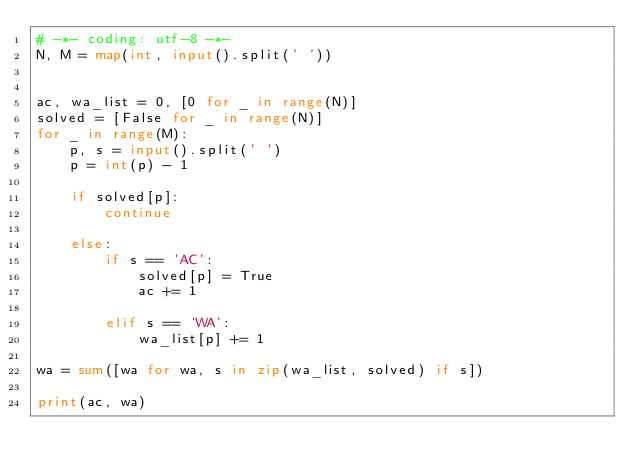<code> <loc_0><loc_0><loc_500><loc_500><_Python_># -*- coding: utf-8 -*-
N, M = map(int, input().split(' '))


ac, wa_list = 0, [0 for _ in range(N)]
solved = [False for _ in range(N)]
for _ in range(M):
    p, s = input().split(' ')
    p = int(p) - 1

    if solved[p]:
        continue

    else:
        if s == 'AC':
            solved[p] = True
            ac += 1

        elif s == 'WA':
            wa_list[p] += 1

wa = sum([wa for wa, s in zip(wa_list, solved) if s])

print(ac, wa)


</code> 